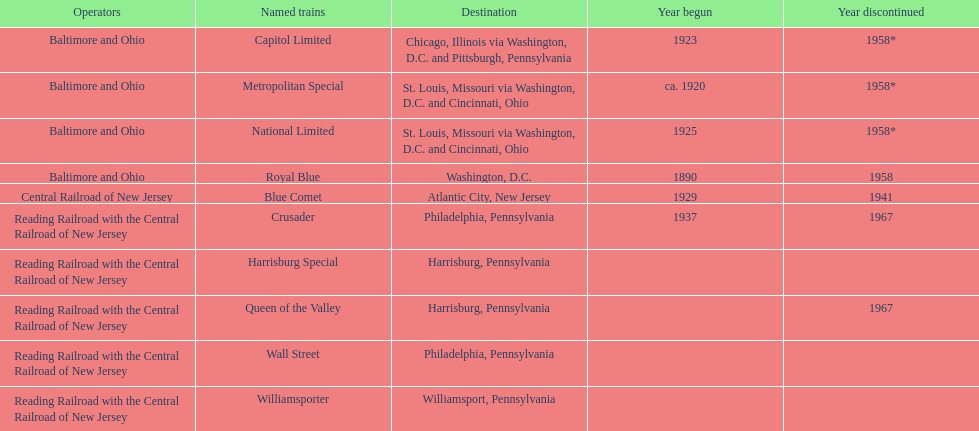What is the total number of year begun? 6. 